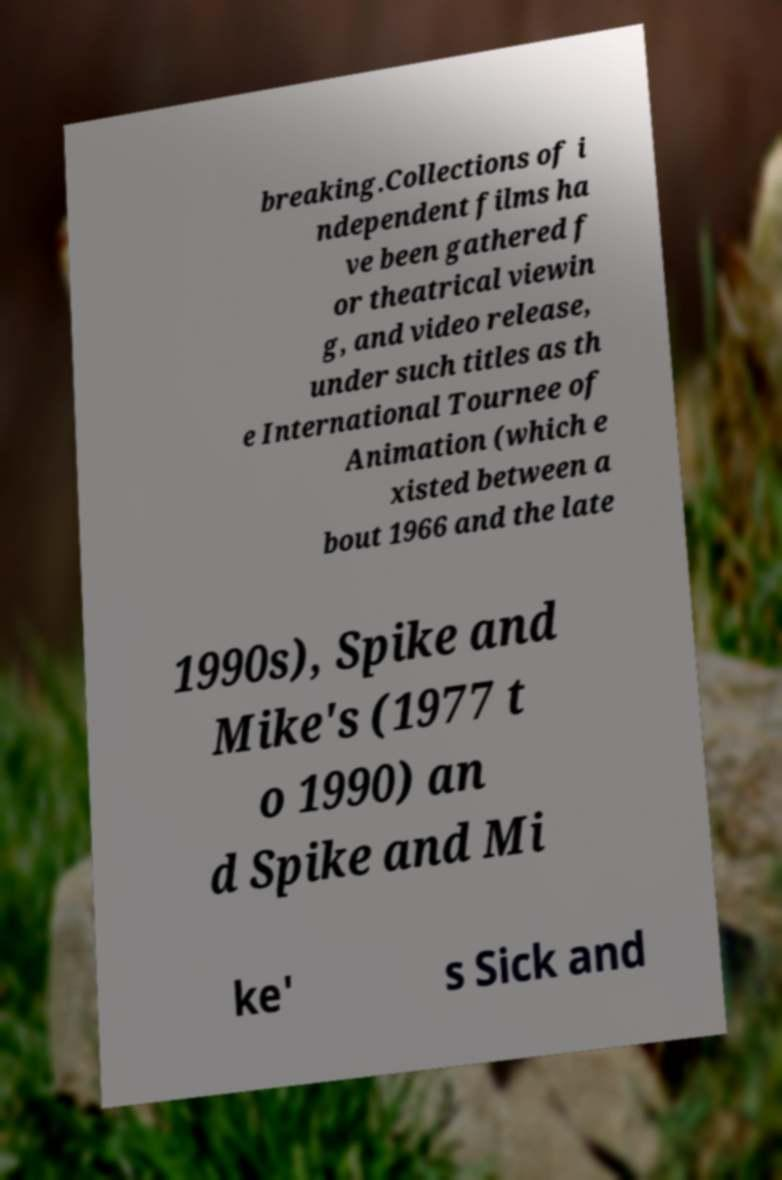I need the written content from this picture converted into text. Can you do that? breaking.Collections of i ndependent films ha ve been gathered f or theatrical viewin g, and video release, under such titles as th e International Tournee of Animation (which e xisted between a bout 1966 and the late 1990s), Spike and Mike's (1977 t o 1990) an d Spike and Mi ke' s Sick and 